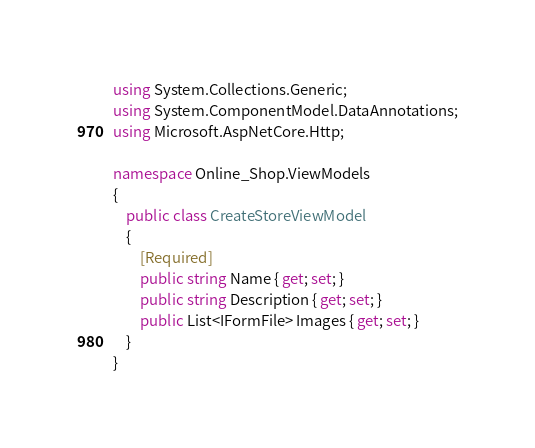Convert code to text. <code><loc_0><loc_0><loc_500><loc_500><_C#_>using System.Collections.Generic;
using System.ComponentModel.DataAnnotations;
using Microsoft.AspNetCore.Http;

namespace Online_Shop.ViewModels
{
    public class CreateStoreViewModel
    {
        [Required]
        public string Name { get; set; }
        public string Description { get; set; }
        public List<IFormFile> Images { get; set; }
    }
}</code> 